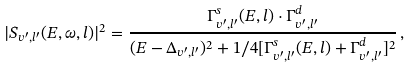<formula> <loc_0><loc_0><loc_500><loc_500>| S _ { v ^ { \prime } , l ^ { \prime } } ( E , \omega , l ) | ^ { 2 } = \frac { \Gamma ^ { s } _ { v ^ { \prime } , l ^ { \prime } } ( E , l ) \cdot \Gamma ^ { d } _ { v ^ { \prime } , l ^ { \prime } } } { ( E - \Delta _ { v ^ { \prime } , l ^ { \prime } } ) ^ { 2 } + 1 / 4 [ \Gamma ^ { s } _ { v ^ { \prime } , l ^ { \prime } } ( E , l ) + \Gamma ^ { d } _ { v ^ { \prime } , l ^ { \prime } } ] ^ { 2 } } \, ,</formula> 